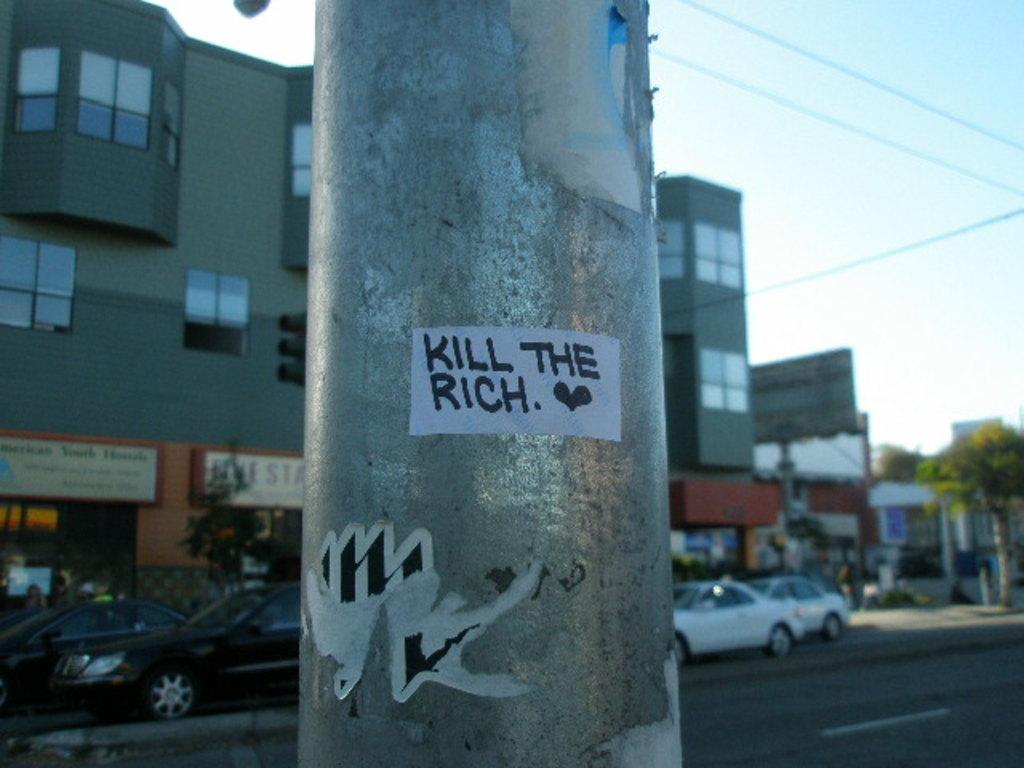What is attached to the pole in the image? There are stickers attached to a pole in the image. What can be seen in the background of the image? There are buildings, trees, vehicles on the road, and the sky visible in the background of the image. What type of coat is hanging on the church in the image? There is no church or coat present in the image. How does the dust affect the visibility of the stickers in the image? There is no mention of dust in the image, so it cannot affect the visibility of the stickers. 